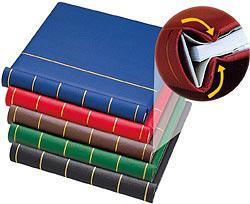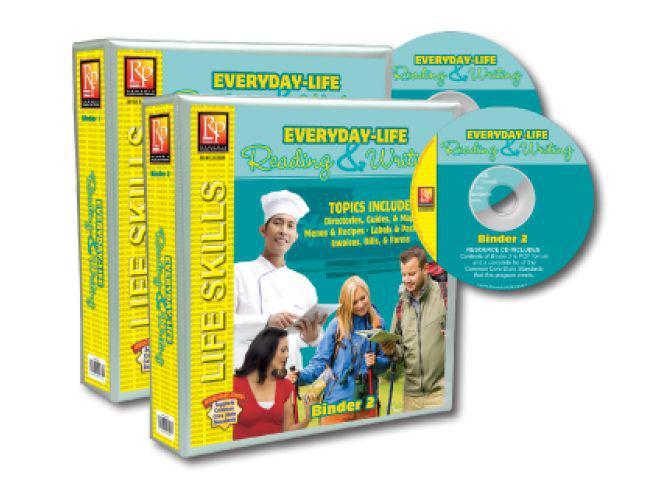The first image is the image on the left, the second image is the image on the right. Assess this claim about the two images: "There is a woman in the image on the right.". Correct or not? Answer yes or no. No. The first image is the image on the left, the second image is the image on the right. For the images shown, is this caption "A person is gripping multiple different colored binders in one of the images." true? Answer yes or no. No. 